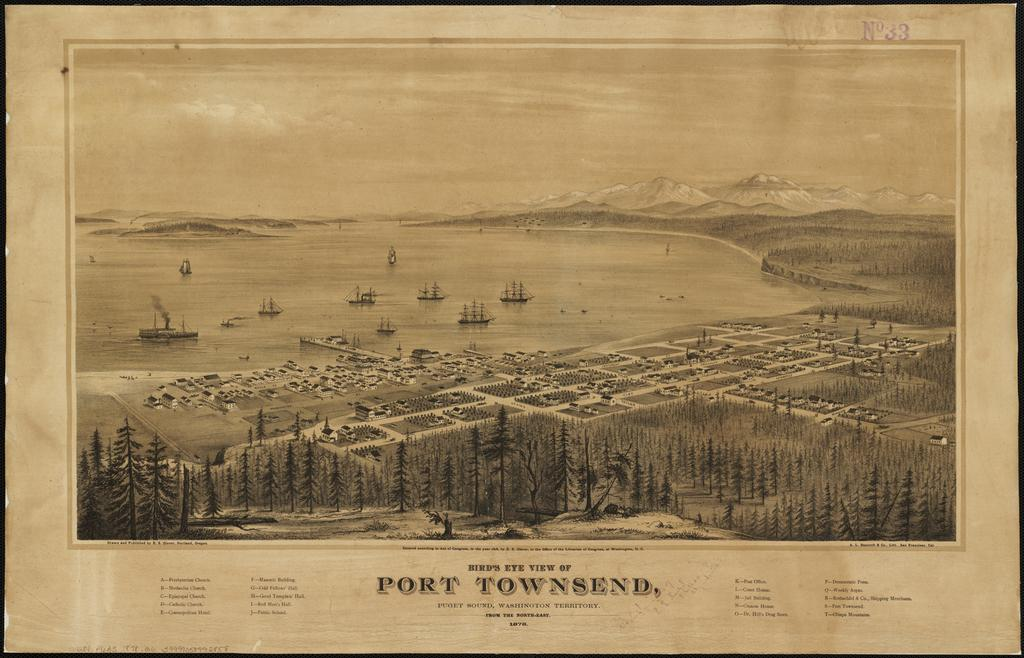<image>
Write a terse but informative summary of the picture. And old post card from Port Townsend that is in sepia color. 